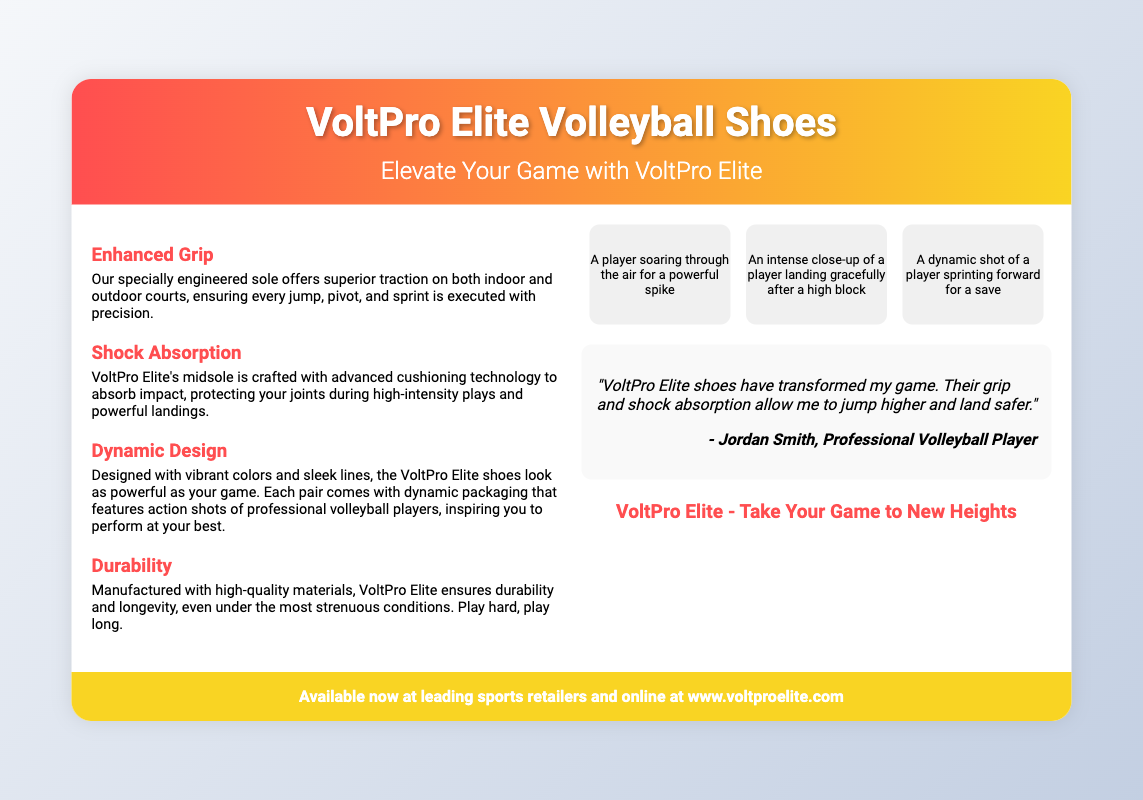What is the name of the product? The name of the product is clearly stated in the header of the document.
Answer: VoltPro Elite Volleyball Shoes What is the primary feature that enhances jumping capabilities? The document highlights the primary feature related to jumping capabilities.
Answer: Enhanced Grip How many dynamic action shots are featured in the visuals section? The visuals section contains multiple action shots showcasing players.
Answer: Three Who provided a quote about the product? The quote in the document attributes the testimonial to a specific individual.
Answer: Jordan Smith What is the main benefit of the shock absorption feature? The document explains the purpose of shock absorption in volleyball shoes.
Answer: Protecting your joints What colors describe the design of the VoltPro Elite shoes? The document specifically mentions characteristics of the design related to color.
Answer: Vibrant colors Where can the VoltPro Elite shoes be purchased? The call to action at the bottom of the document indicates where to buy the product.
Answer: Leading sports retailers and online What is the slogan for the VoltPro Elite shoes? The slogan summarizing the marketing message is provided in a specific section.
Answer: Take Your Game to New Heights 